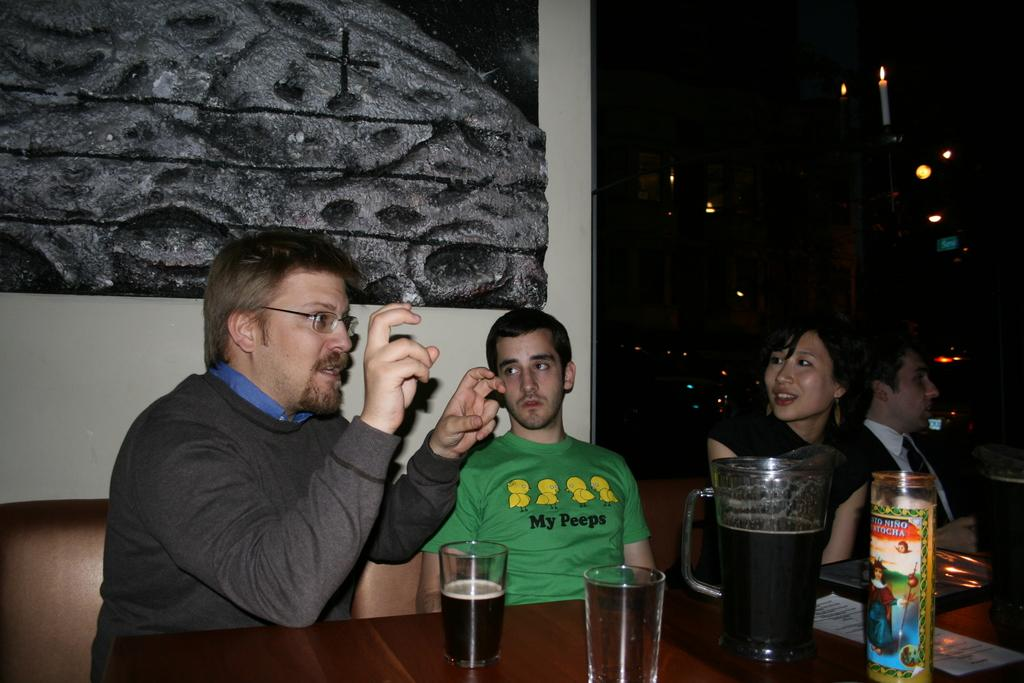<image>
Render a clear and concise summary of the photo. A man makes a quotes sign with his fingers while sitting next to a man wearing a t-shirt with a bird pun on it. 